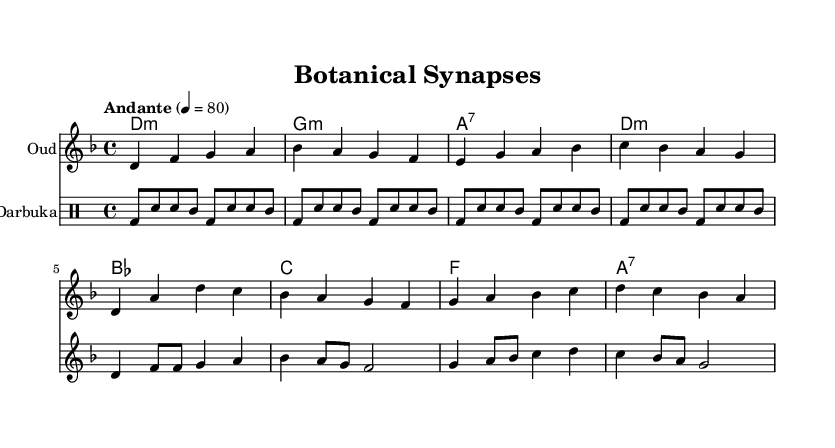What is the key signature of this music? The key signature indicates D minor, which has one flat (B flat). This is determined by the presence of the flat sign on the B note in the key signature.
Answer: D minor What is the time signature used in this composition? The time signature is 4/4, which indicates there are four beats per measure and the quarter note gets one beat. This is shown at the beginning of the music.
Answer: 4/4 What is the tempo marking of this piece? The tempo marking is "Andante," which suggests a moderately slow pace, typically ranging from 76 to 108 beats per minute. This is indicated in the tempo notation at the start of the music.
Answer: Andante How many measures are present in the oud part? There are 8 measures in the oud part, as each distinct grouping of notes divided by vertical lines represents one measure. Counting each grouping confirms the total.
Answer: 8 Which musical instrument is notated with the highest range in this score? The voice part is notated with the highest range, as it has notes like d' and f', which are higher than the notes of the oud or darbuka sections. Comparing the pitches reveals that the voice reaches higher notes.
Answer: Voice What type of lyrics are associated with the music? The lyrics explore themes of ethnobotany and neuroscience, particularly the intricate relationship between minds and nature as reflected in the verse. The content of the lyrics suggests a merging of these fields.
Answer: Ethnobotany and neuroscience What rhythmic pattern does the darbuka use in the first measure? The first measure of the darbuka part consists of a bass drum hit followed by two snare hits and a tom-tom, creating a distinct Middle Eastern rhythmic pattern. This pattern involves a combination of beats indicated specifically in the drumming notation.
Answer: bass-drum, snare, tom 